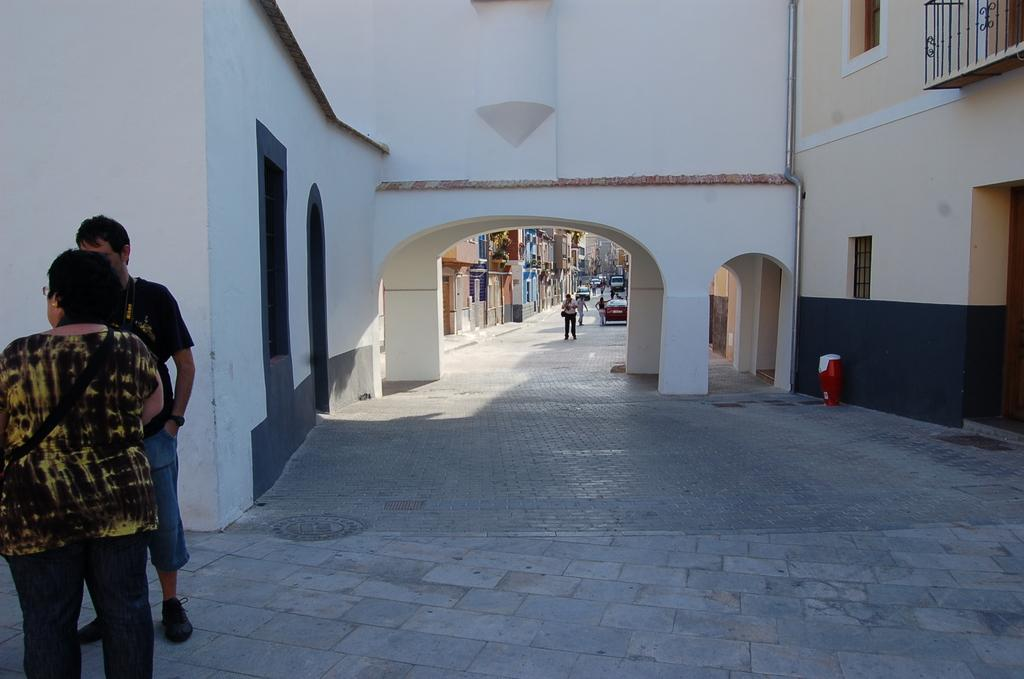What are the people in the image doing? The people in the image are standing on the ground. What can be seen on the road in the image? There are cars parked on the road. What is visible in the distance in the image? There are buildings visible in the background. What type of grape is being used to create a list in the image? There is no grape or list present in the image. 